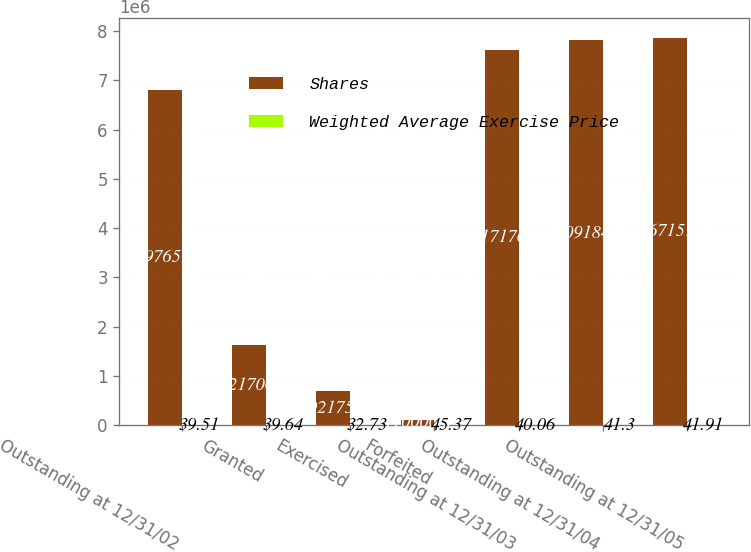<chart> <loc_0><loc_0><loc_500><loc_500><stacked_bar_chart><ecel><fcel>Outstanding at 12/31/02<fcel>Granted<fcel>Exercised<fcel>Forfeited<fcel>Outstanding at 12/31/03<fcel>Outstanding at 12/31/04<fcel>Outstanding at 12/31/05<nl><fcel>Shares<fcel>6.79765e+06<fcel>1.6217e+06<fcel>692175<fcel>110000<fcel>7.61718e+06<fcel>7.80918e+06<fcel>7.86715e+06<nl><fcel>Weighted Average Exercise Price<fcel>39.51<fcel>39.64<fcel>32.73<fcel>45.37<fcel>40.06<fcel>41.3<fcel>41.91<nl></chart> 